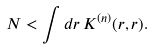Convert formula to latex. <formula><loc_0><loc_0><loc_500><loc_500>N < \int d { r } \, K ^ { ( n ) } ( { r } , { r } ) .</formula> 